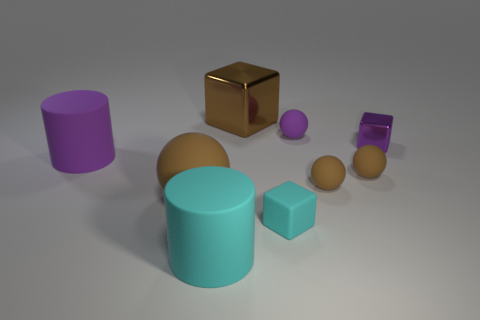Subtract all yellow cylinders. How many brown spheres are left? 3 Subtract 1 balls. How many balls are left? 3 Add 1 small yellow metal cylinders. How many objects exist? 10 Subtract all cubes. How many objects are left? 6 Subtract all large cubes. Subtract all tiny yellow balls. How many objects are left? 8 Add 9 big brown matte balls. How many big brown matte balls are left? 10 Add 3 small blue matte objects. How many small blue matte objects exist? 3 Subtract 0 brown cylinders. How many objects are left? 9 